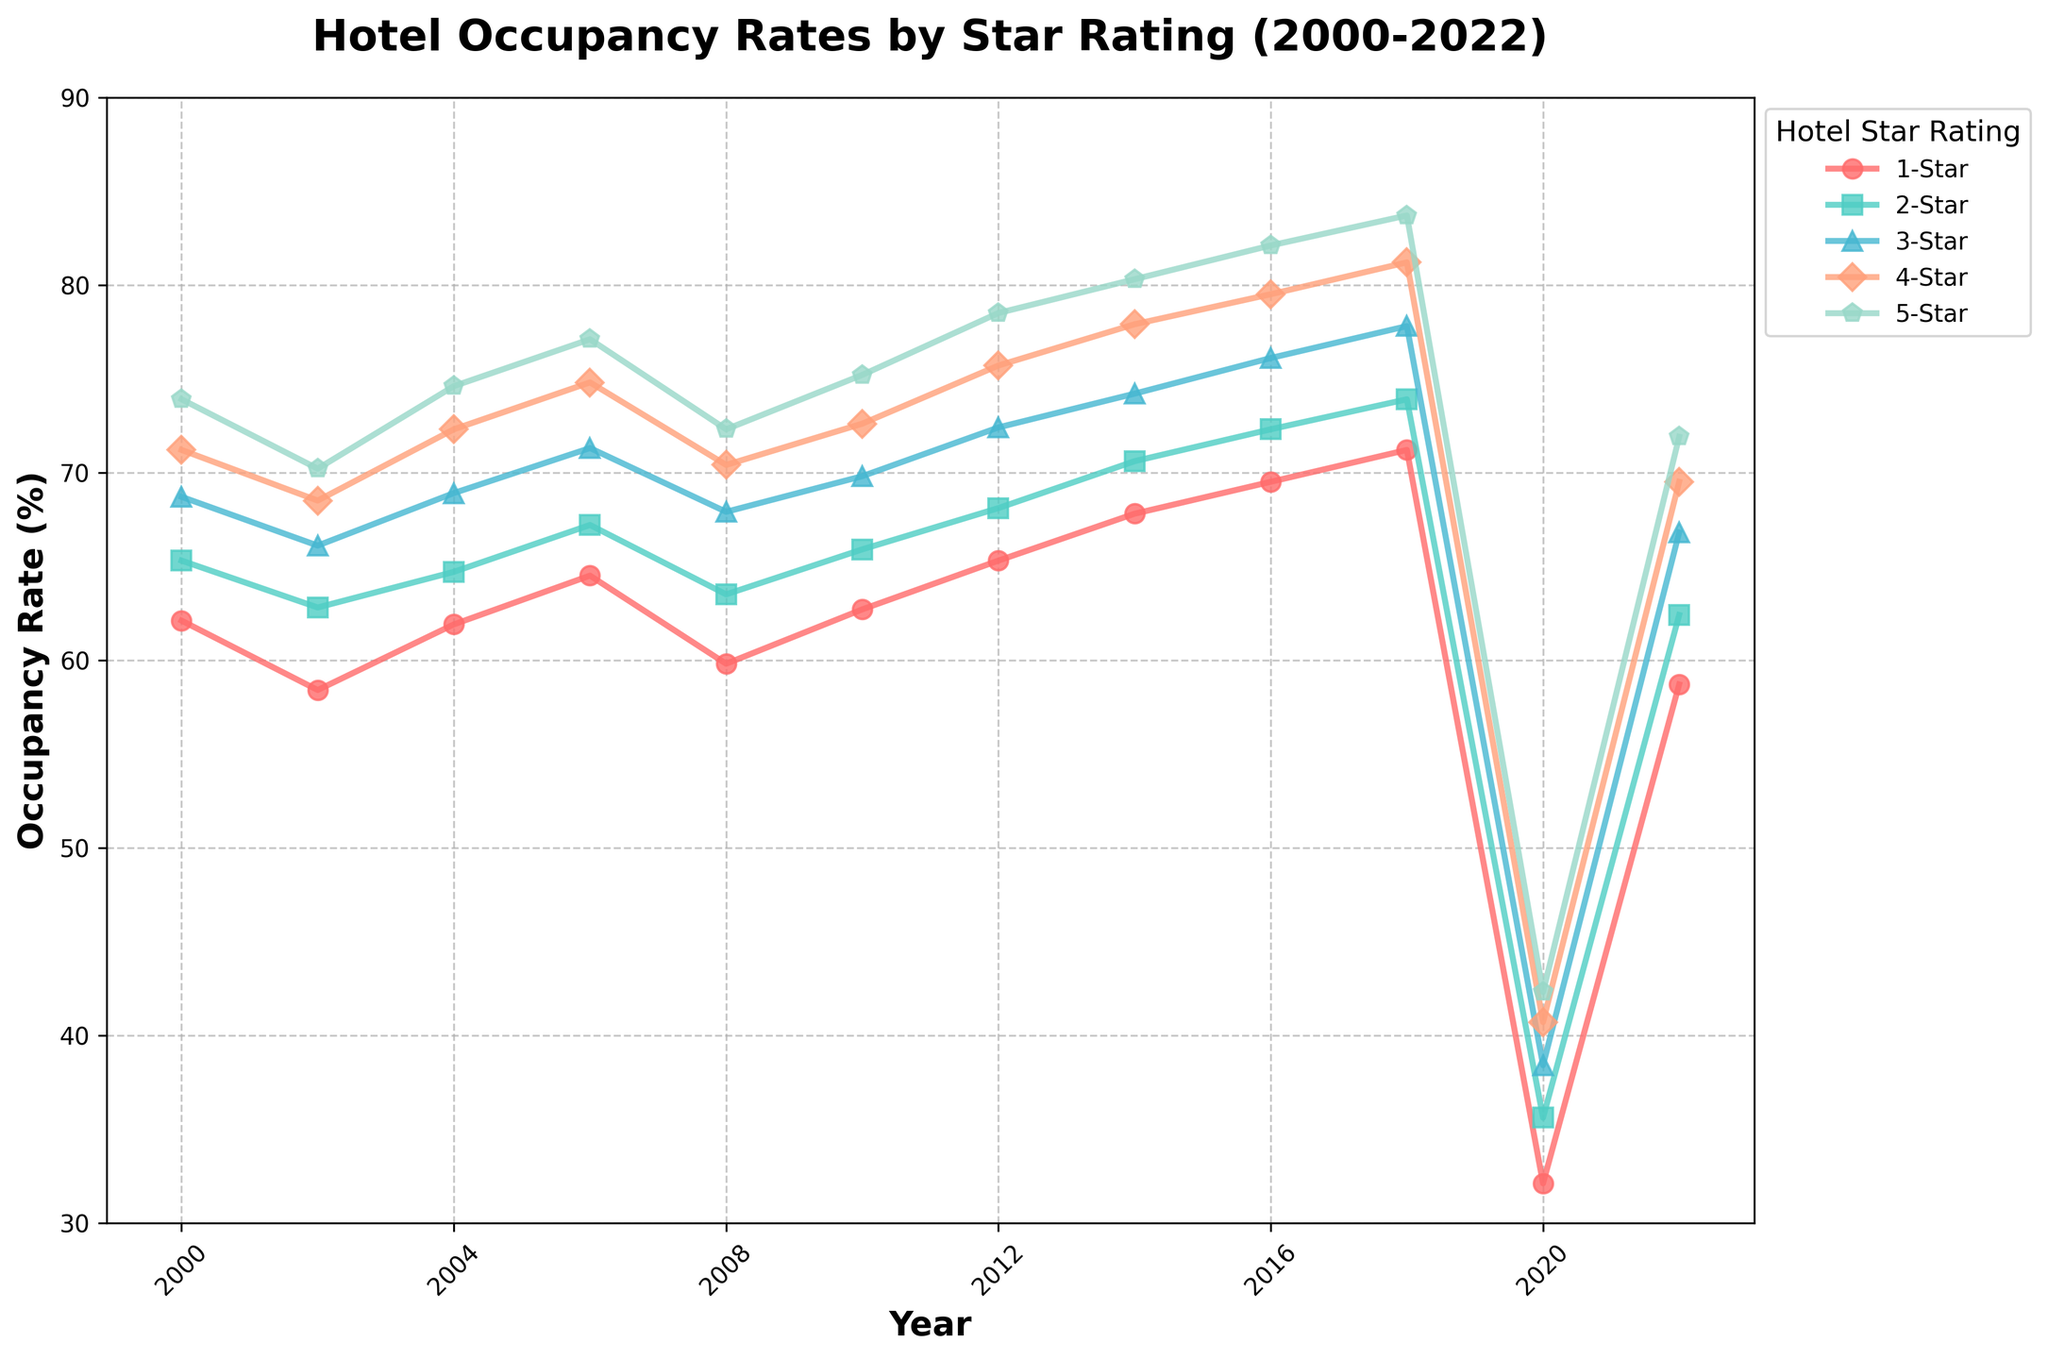What's the general trend for 5-Star hotels from 2000 to 2022? To identify the general trend, observe the line representing 5-Star hotels from 2000 to 2022 on the plot. The line rises from around 73.9% in 2000 to 83.7% in 2018, drops substantially to 42.3% in 2020, and recovers to 71.9% in 2022. Overall, the trend is an increase but with a significant drop in 2020 and partial recovery by 2022.
Answer: Increasing with a drop in 2020 Which star rating had the largest drop in occupancy rate in 2020 compared to 2018? Compare the occupancy rates for each star rating in 2018 and 2020. The drop for 1-Star hotels is 71.2% to 32.1%, for 2-Star is 73.9% to 35.6%, for 3-Star is 77.8% to 38.4%, for 4-Star is 81.2% to 40.7%, and for 5-Star is 83.7% to 42.3%. The largest drop is for 1-Star hotels: 71.2% - 32.1% = 39.1%.
Answer: 1-Star In which year did the 3-Star hotels have the highest occupancy rate? Observe the line representing 3-Star hotels and identify the peak point. The highest occupancy rate is 77.8%, which occurs in 2018.
Answer: 2018 How did the occupancy rate for 4-Star hotels change from 2008 to 2014? Check the occupancy rates for 4-Star hotels in 2008 and 2014. In 2008 it was 70.4%, and in 2014 it increased to 77.9%. Compute the change: 77.9% - 70.4% = 7.5%.
Answer: Increased by 7.5% What was the difference in occupancy rates between 2-Star and 5-Star hotels in 2010? Locate the occupancy rates for 2-Star and 5-Star hotels in 2010. The occupancy rate for 2-Star hotels was 65.9% and for 5-Star hotels, it was 75.2%. Compute the difference: 75.2% - 65.9% = 9.3%.
Answer: 9.3% Between 2012 and 2016, which star rating had the least increase in occupancy rate? Calculate the increase for each star rating between 2012 and 2016:
- 1-Star: 69.5% - 65.3% = 4.2%
- 2-Star: 72.3% - 68.1% = 4.2%
- 3-Star: 76.1% - 72.4% = 3.7%
- 4-Star: 79.5% - 75.7% = 3.8%
- 5-Star: 82.1% - 78.5% = 3.6% 
The 5-Star hotels had the least increase of 3.6%.
Answer: 5-Star In 2004, how did the occupancy rates compare among different star ratings? Locate the occupancy rates for each star rating in 2004. The values are: 1-Star: 61.9%, 2-Star: 64.7%, 3-Star: 68.9%, 4-Star: 72.3%, 5-Star: 74.6%. Rank these from lowest to highest for a comparison:
1-Star < 2-Star < 3-Star < 4-Star < 5-Star.
Answer: 1-Star < 2-Star < 3-Star < 4-Star < 5-Star What's the average occupancy rate of 3-Star hotels over the years provided in the data? Sum the occupancy rates of 3-Star hotels for each year and divide by the number of years. The rates are: 68.7, 66.1, 68.9, 71.3, 67.9, 69.8, 72.4, 74.2, 76.1, 77.8, 38.4, and 66.8. Compute the sum: 68.7 + 66.1 + 68.9 + 71.3 + 67.9 + 69.8 + 72.4 + 74.2 + 76.1 + 77.8 + 38.4 + 66.8 = 818.4. Divide by 12: 818.4 / 12 = 68.2.
Answer: 68.2% 